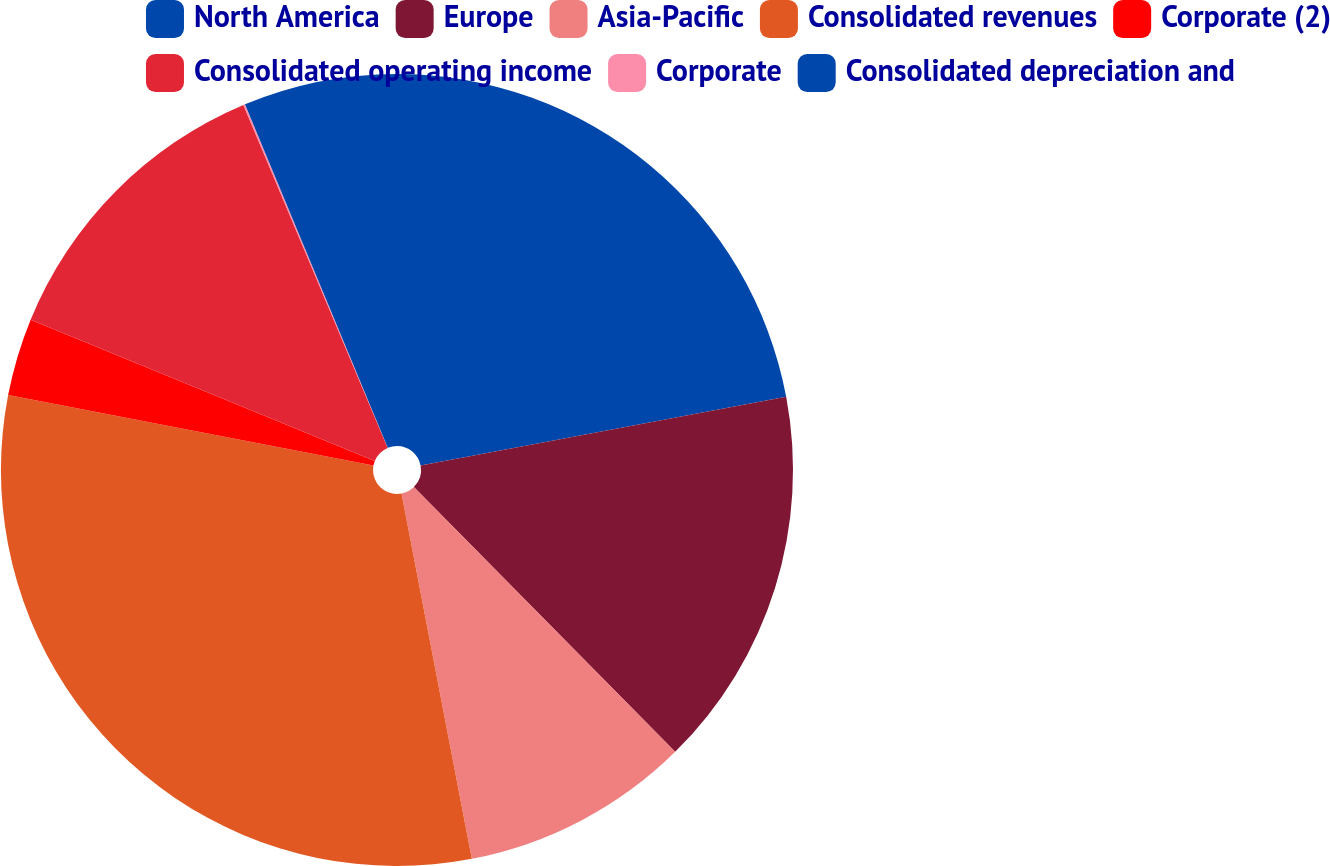Convert chart. <chart><loc_0><loc_0><loc_500><loc_500><pie_chart><fcel>North America<fcel>Europe<fcel>Asia-Pacific<fcel>Consolidated revenues<fcel>Corporate (2)<fcel>Consolidated operating income<fcel>Corporate<fcel>Consolidated depreciation and<nl><fcel>22.04%<fcel>15.56%<fcel>9.37%<fcel>31.05%<fcel>3.17%<fcel>12.46%<fcel>0.07%<fcel>6.27%<nl></chart> 